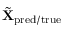<formula> <loc_0><loc_0><loc_500><loc_500>\tilde { X } _ { p r e d / t r u e }</formula> 